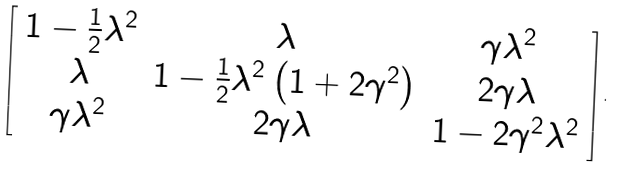<formula> <loc_0><loc_0><loc_500><loc_500>\left [ \begin{array} { c c c } 1 - \frac { 1 } { 2 } \lambda ^ { 2 } & \lambda & \gamma \lambda ^ { 2 } \\ \lambda & 1 - \frac { 1 } { 2 } \lambda ^ { 2 } \left ( 1 + 2 \gamma ^ { 2 } \right ) & 2 \gamma \lambda \\ \gamma \lambda ^ { 2 } & 2 \gamma \lambda & 1 - 2 \gamma ^ { 2 } \lambda ^ { 2 } \end{array} \right ] .</formula> 